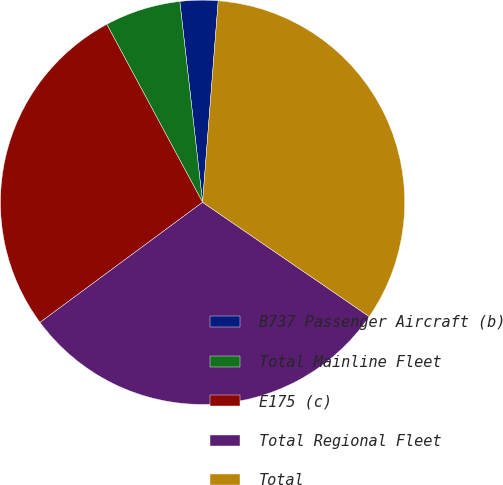Convert chart to OTSL. <chart><loc_0><loc_0><loc_500><loc_500><pie_chart><fcel>B737 Passenger Aircraft (b)<fcel>Total Mainline Fleet<fcel>E175 (c)<fcel>Total Regional Fleet<fcel>Total<nl><fcel>3.03%<fcel>6.06%<fcel>27.27%<fcel>30.3%<fcel>33.33%<nl></chart> 